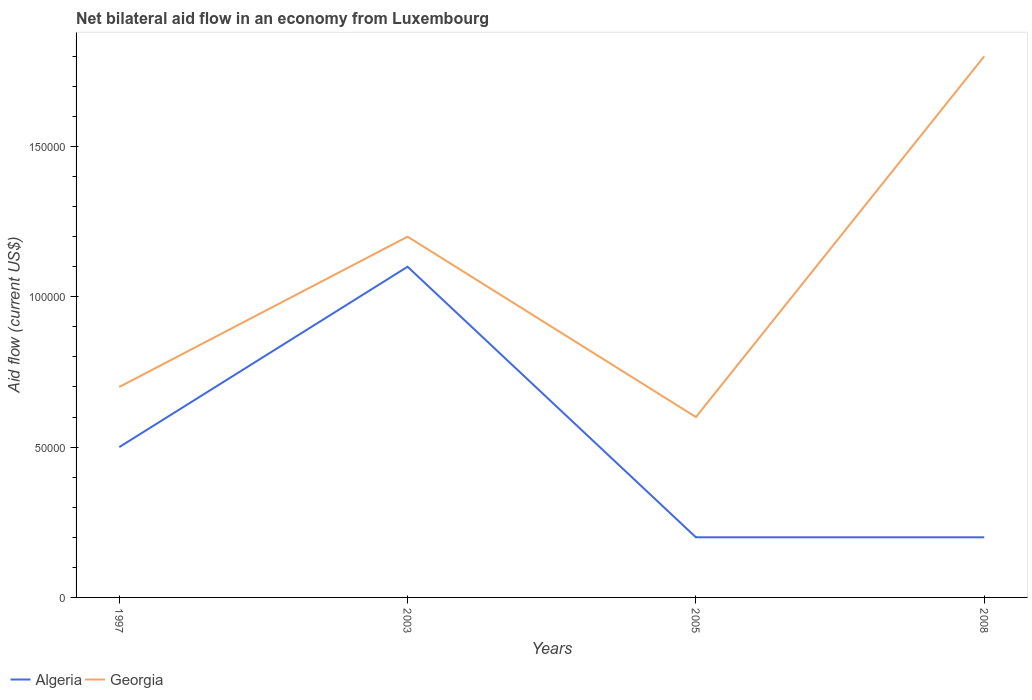How many different coloured lines are there?
Ensure brevity in your answer.  2. Is the number of lines equal to the number of legend labels?
Your response must be concise. Yes. Across all years, what is the maximum net bilateral aid flow in Algeria?
Offer a very short reply. 2.00e+04. Is the net bilateral aid flow in Algeria strictly greater than the net bilateral aid flow in Georgia over the years?
Your response must be concise. Yes. How many years are there in the graph?
Provide a succinct answer. 4. Are the values on the major ticks of Y-axis written in scientific E-notation?
Give a very brief answer. No. Does the graph contain any zero values?
Give a very brief answer. No. Where does the legend appear in the graph?
Your answer should be compact. Bottom left. What is the title of the graph?
Your response must be concise. Net bilateral aid flow in an economy from Luxembourg. Does "Euro area" appear as one of the legend labels in the graph?
Give a very brief answer. No. What is the label or title of the X-axis?
Offer a very short reply. Years. What is the Aid flow (current US$) of Algeria in 1997?
Ensure brevity in your answer.  5.00e+04. What is the Aid flow (current US$) of Georgia in 1997?
Offer a terse response. 7.00e+04. What is the Aid flow (current US$) of Algeria in 2003?
Your response must be concise. 1.10e+05. What is the Aid flow (current US$) in Georgia in 2003?
Provide a short and direct response. 1.20e+05. What is the Aid flow (current US$) in Algeria in 2005?
Provide a short and direct response. 2.00e+04. What is the Aid flow (current US$) in Algeria in 2008?
Provide a short and direct response. 2.00e+04. Across all years, what is the maximum Aid flow (current US$) of Algeria?
Your answer should be very brief. 1.10e+05. Across all years, what is the maximum Aid flow (current US$) in Georgia?
Your answer should be compact. 1.80e+05. Across all years, what is the minimum Aid flow (current US$) in Algeria?
Your answer should be very brief. 2.00e+04. Across all years, what is the minimum Aid flow (current US$) of Georgia?
Your answer should be very brief. 6.00e+04. What is the total Aid flow (current US$) in Algeria in the graph?
Give a very brief answer. 2.00e+05. What is the difference between the Aid flow (current US$) in Algeria in 1997 and that in 2003?
Ensure brevity in your answer.  -6.00e+04. What is the difference between the Aid flow (current US$) in Algeria in 1997 and that in 2005?
Your answer should be compact. 3.00e+04. What is the difference between the Aid flow (current US$) in Georgia in 1997 and that in 2008?
Offer a terse response. -1.10e+05. What is the difference between the Aid flow (current US$) of Algeria in 2003 and that in 2005?
Offer a very short reply. 9.00e+04. What is the difference between the Aid flow (current US$) in Georgia in 2003 and that in 2005?
Provide a succinct answer. 6.00e+04. What is the difference between the Aid flow (current US$) in Algeria in 2003 and that in 2008?
Provide a succinct answer. 9.00e+04. What is the difference between the Aid flow (current US$) of Georgia in 2003 and that in 2008?
Give a very brief answer. -6.00e+04. What is the difference between the Aid flow (current US$) of Algeria in 2005 and that in 2008?
Offer a terse response. 0. What is the difference between the Aid flow (current US$) in Algeria in 1997 and the Aid flow (current US$) in Georgia in 2003?
Offer a terse response. -7.00e+04. What is the difference between the Aid flow (current US$) of Algeria in 1997 and the Aid flow (current US$) of Georgia in 2008?
Provide a succinct answer. -1.30e+05. What is the difference between the Aid flow (current US$) of Algeria in 2003 and the Aid flow (current US$) of Georgia in 2008?
Keep it short and to the point. -7.00e+04. What is the difference between the Aid flow (current US$) in Algeria in 2005 and the Aid flow (current US$) in Georgia in 2008?
Your response must be concise. -1.60e+05. What is the average Aid flow (current US$) of Algeria per year?
Your answer should be very brief. 5.00e+04. What is the average Aid flow (current US$) in Georgia per year?
Your answer should be very brief. 1.08e+05. In the year 2005, what is the difference between the Aid flow (current US$) of Algeria and Aid flow (current US$) of Georgia?
Keep it short and to the point. -4.00e+04. What is the ratio of the Aid flow (current US$) of Algeria in 1997 to that in 2003?
Provide a succinct answer. 0.45. What is the ratio of the Aid flow (current US$) in Georgia in 1997 to that in 2003?
Provide a succinct answer. 0.58. What is the ratio of the Aid flow (current US$) in Algeria in 1997 to that in 2005?
Offer a terse response. 2.5. What is the ratio of the Aid flow (current US$) in Algeria in 1997 to that in 2008?
Your answer should be compact. 2.5. What is the ratio of the Aid flow (current US$) of Georgia in 1997 to that in 2008?
Provide a succinct answer. 0.39. What is the ratio of the Aid flow (current US$) of Georgia in 2003 to that in 2008?
Offer a very short reply. 0.67. What is the ratio of the Aid flow (current US$) of Algeria in 2005 to that in 2008?
Give a very brief answer. 1. What is the ratio of the Aid flow (current US$) in Georgia in 2005 to that in 2008?
Your answer should be very brief. 0.33. What is the difference between the highest and the second highest Aid flow (current US$) of Algeria?
Provide a short and direct response. 6.00e+04. What is the difference between the highest and the lowest Aid flow (current US$) of Georgia?
Offer a very short reply. 1.20e+05. 